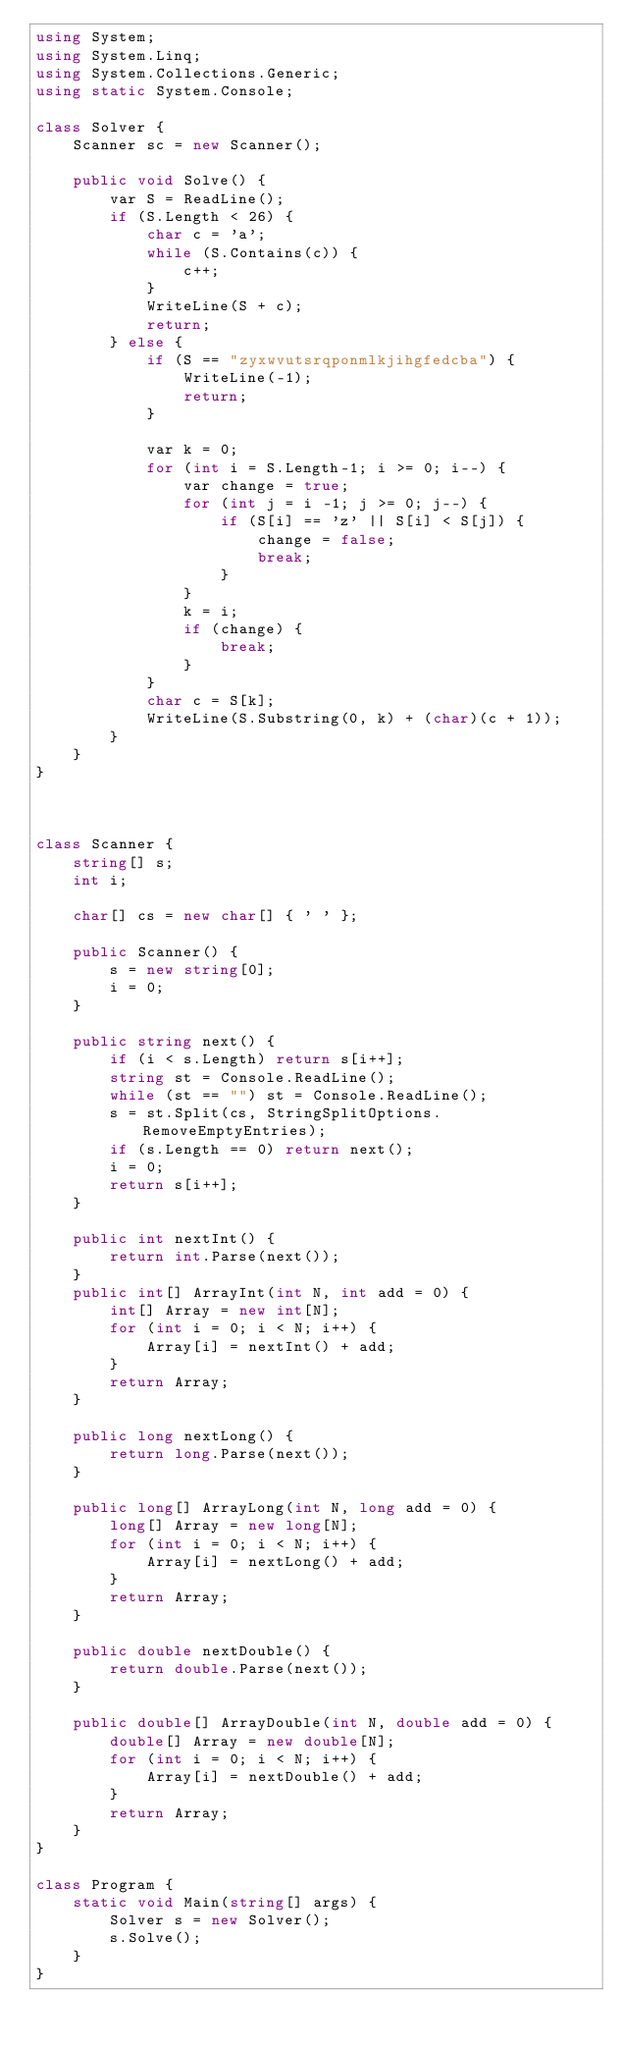<code> <loc_0><loc_0><loc_500><loc_500><_C#_>using System;
using System.Linq;
using System.Collections.Generic;
using static System.Console;

class Solver {
    Scanner sc = new Scanner();

    public void Solve() {
        var S = ReadLine();
        if (S.Length < 26) {
            char c = 'a';
            while (S.Contains(c)) {
                c++;
            }
            WriteLine(S + c);
            return;
        } else {
            if (S == "zyxwvutsrqponmlkjihgfedcba") {
                WriteLine(-1);
                return;
            }

            var k = 0;
            for (int i = S.Length-1; i >= 0; i--) {
                var change = true;
                for (int j = i -1; j >= 0; j--) {
                    if (S[i] == 'z' || S[i] < S[j]) {
                        change = false;
                        break;
                    }
                }
                k = i;
                if (change) {
                    break;
                }
            }
            char c = S[k];
            WriteLine(S.Substring(0, k) + (char)(c + 1));
        }
    }
}



class Scanner {
    string[] s;
    int i;

    char[] cs = new char[] { ' ' };

    public Scanner() {
        s = new string[0];
        i = 0;
    }

    public string next() {
        if (i < s.Length) return s[i++];
        string st = Console.ReadLine();
        while (st == "") st = Console.ReadLine();
        s = st.Split(cs, StringSplitOptions.RemoveEmptyEntries);
        if (s.Length == 0) return next();
        i = 0;
        return s[i++];
    }

    public int nextInt() {
        return int.Parse(next());
    }
    public int[] ArrayInt(int N, int add = 0) {
        int[] Array = new int[N];
        for (int i = 0; i < N; i++) {
            Array[i] = nextInt() + add;
        }
        return Array;
    }

    public long nextLong() {
        return long.Parse(next());
    }

    public long[] ArrayLong(int N, long add = 0) {
        long[] Array = new long[N];
        for (int i = 0; i < N; i++) {
            Array[i] = nextLong() + add;
        }
        return Array;
    }

    public double nextDouble() {
        return double.Parse(next());
    }

    public double[] ArrayDouble(int N, double add = 0) {
        double[] Array = new double[N];
        for (int i = 0; i < N; i++) {
            Array[i] = nextDouble() + add;
        }
        return Array;
    }
}

class Program {
    static void Main(string[] args) {
        Solver s = new Solver();
        s.Solve();
    }
}
</code> 